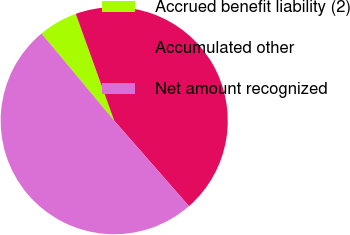<chart> <loc_0><loc_0><loc_500><loc_500><pie_chart><fcel>Accrued benefit liability (2)<fcel>Accumulated other<fcel>Net amount recognized<nl><fcel>5.56%<fcel>44.06%<fcel>50.38%<nl></chart> 